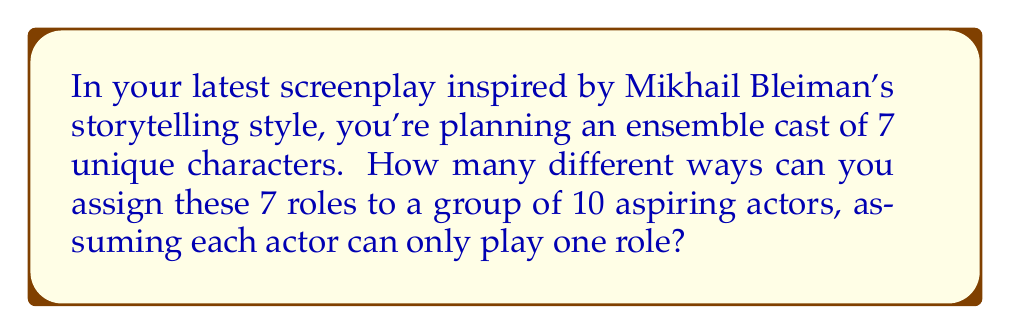Can you answer this question? Let's approach this step-by-step:

1) This problem is a perfect example of a permutation with distinction. We are selecting 7 actors out of 10 to fill 7 distinct roles.

2) The order matters here because each role is unique, and switching actors between roles creates a new arrangement.

3) We can use the permutation formula:
   
   $$P(n,r) = \frac{n!}{(n-r)!}$$

   Where $n$ is the total number of actors (10) and $r$ is the number of roles (7).

4) Plugging in our values:

   $$P(10,7) = \frac{10!}{(10-7)!} = \frac{10!}{3!}$$

5) Expanding this:
   
   $$\frac{10 \times 9 \times 8 \times 7 \times 6 \times 5 \times 4 \times 3!}{3!}$$

6) The $3!$ cancels out in the numerator and denominator:

   $$10 \times 9 \times 8 \times 7 \times 6 \times 5 \times 4 = 604,800$$

Therefore, there are 604,800 unique ways to distribute the 7 roles among the 10 actors.
Answer: 604,800 